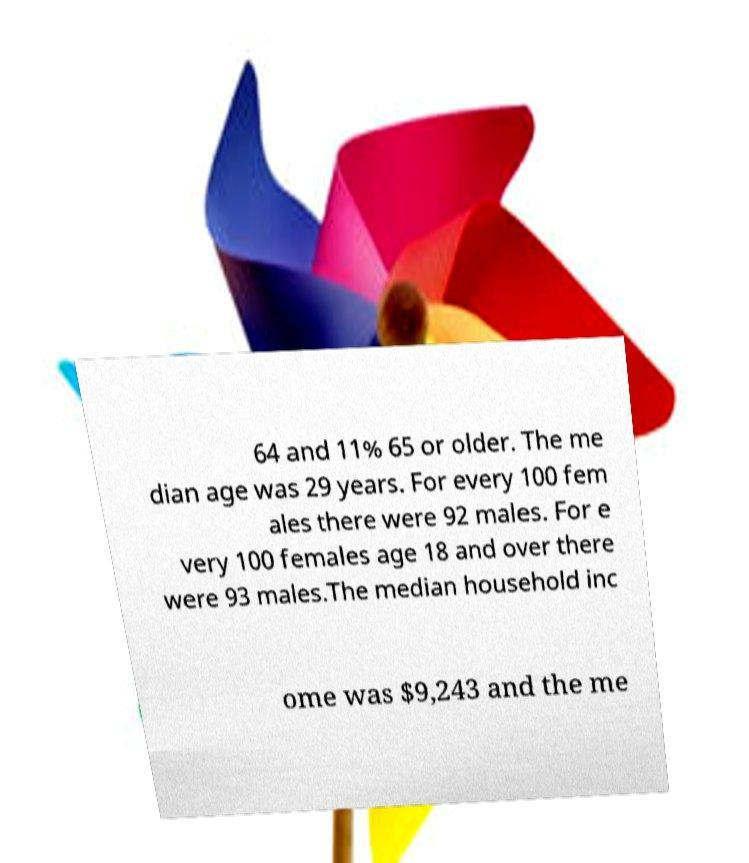Can you read and provide the text displayed in the image?This photo seems to have some interesting text. Can you extract and type it out for me? 64 and 11% 65 or older. The me dian age was 29 years. For every 100 fem ales there were 92 males. For e very 100 females age 18 and over there were 93 males.The median household inc ome was $9,243 and the me 